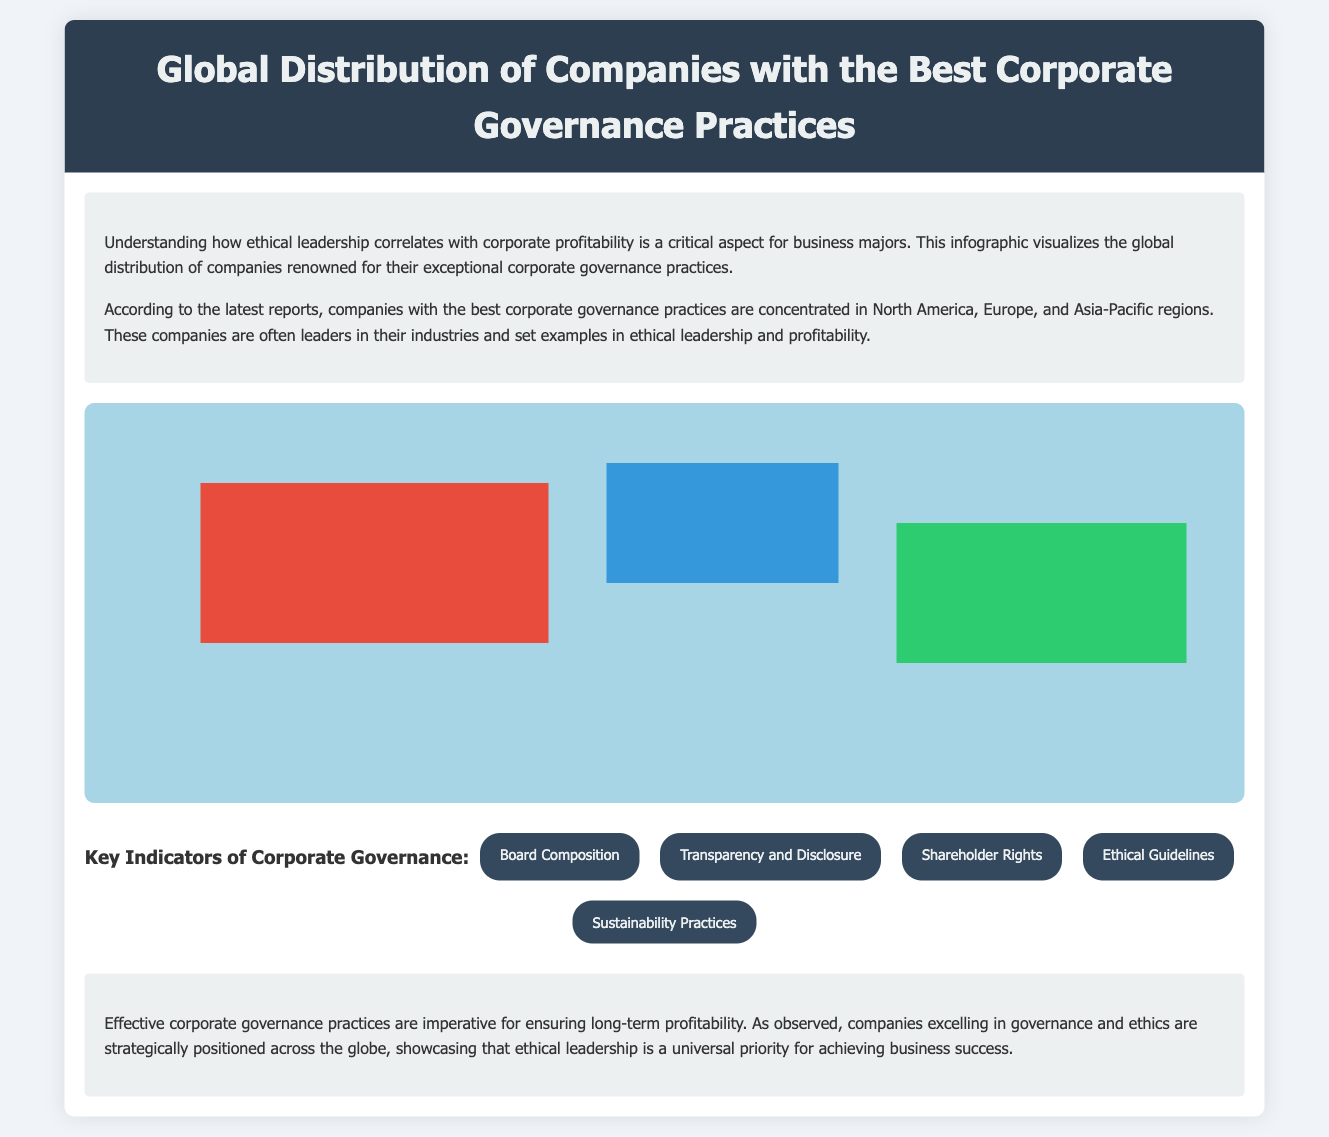What are the regions highlighted for companies with the best corporate governance? The document highlights North America, Europe, and Asia-Pacific as the regions where companies with the best corporate governance are concentrated.
Answer: North America, Europe, Asia-Pacific Which company is mentioned as being based in the United States? The document lists Microsoft Corporation as a company based in the United States.
Answer: Microsoft Corporation What ethical aspect is emphasized in Unilever's corporate governance? The document indicates that Unilever emphasizes transparency and ethical decision-making in its corporate governance practices.
Answer: Transparency and ethical decision-making What is a key indicator of corporate governance mentioned in the document? The document lists Board Composition as one of the key indicators of corporate governance.
Answer: Board Composition Which company is noted for its strong governance practices and is based in Japan? The document refers to Toyota Motor Corporation as the company based in Japan known for strong governance practices.
Answer: Toyota Motor Corporation How many companies are mentioned for Asia-Pacific? The document mentions two companies located in the Asia-Pacific region.
Answer: Two What common trait do companies with the best corporate governance practices share according to the infographic? The document suggests that companies sharing exceptional governance practices often demonstrate strong ethical leadership and profitability.
Answer: Strong ethical leadership and profitability What is the background color of the map container in the infographic? The background color of the map container is specified as a light blue shade in the style section of the document.
Answer: Light blue Which country is Nestlé S.A. associated with? The document associates Nestlé S.A. with Switzerland.
Answer: Switzerland 